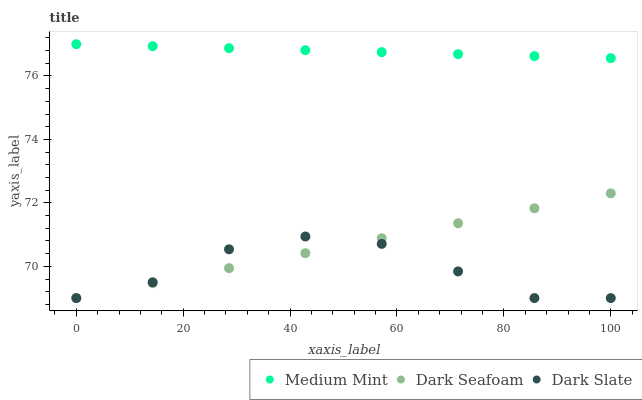Does Dark Slate have the minimum area under the curve?
Answer yes or no. Yes. Does Medium Mint have the maximum area under the curve?
Answer yes or no. Yes. Does Dark Seafoam have the minimum area under the curve?
Answer yes or no. No. Does Dark Seafoam have the maximum area under the curve?
Answer yes or no. No. Is Dark Seafoam the smoothest?
Answer yes or no. Yes. Is Dark Slate the roughest?
Answer yes or no. Yes. Is Dark Slate the smoothest?
Answer yes or no. No. Is Dark Seafoam the roughest?
Answer yes or no. No. Does Dark Slate have the lowest value?
Answer yes or no. Yes. Does Medium Mint have the highest value?
Answer yes or no. Yes. Does Dark Seafoam have the highest value?
Answer yes or no. No. Is Dark Slate less than Medium Mint?
Answer yes or no. Yes. Is Medium Mint greater than Dark Slate?
Answer yes or no. Yes. Does Dark Slate intersect Dark Seafoam?
Answer yes or no. Yes. Is Dark Slate less than Dark Seafoam?
Answer yes or no. No. Is Dark Slate greater than Dark Seafoam?
Answer yes or no. No. Does Dark Slate intersect Medium Mint?
Answer yes or no. No. 